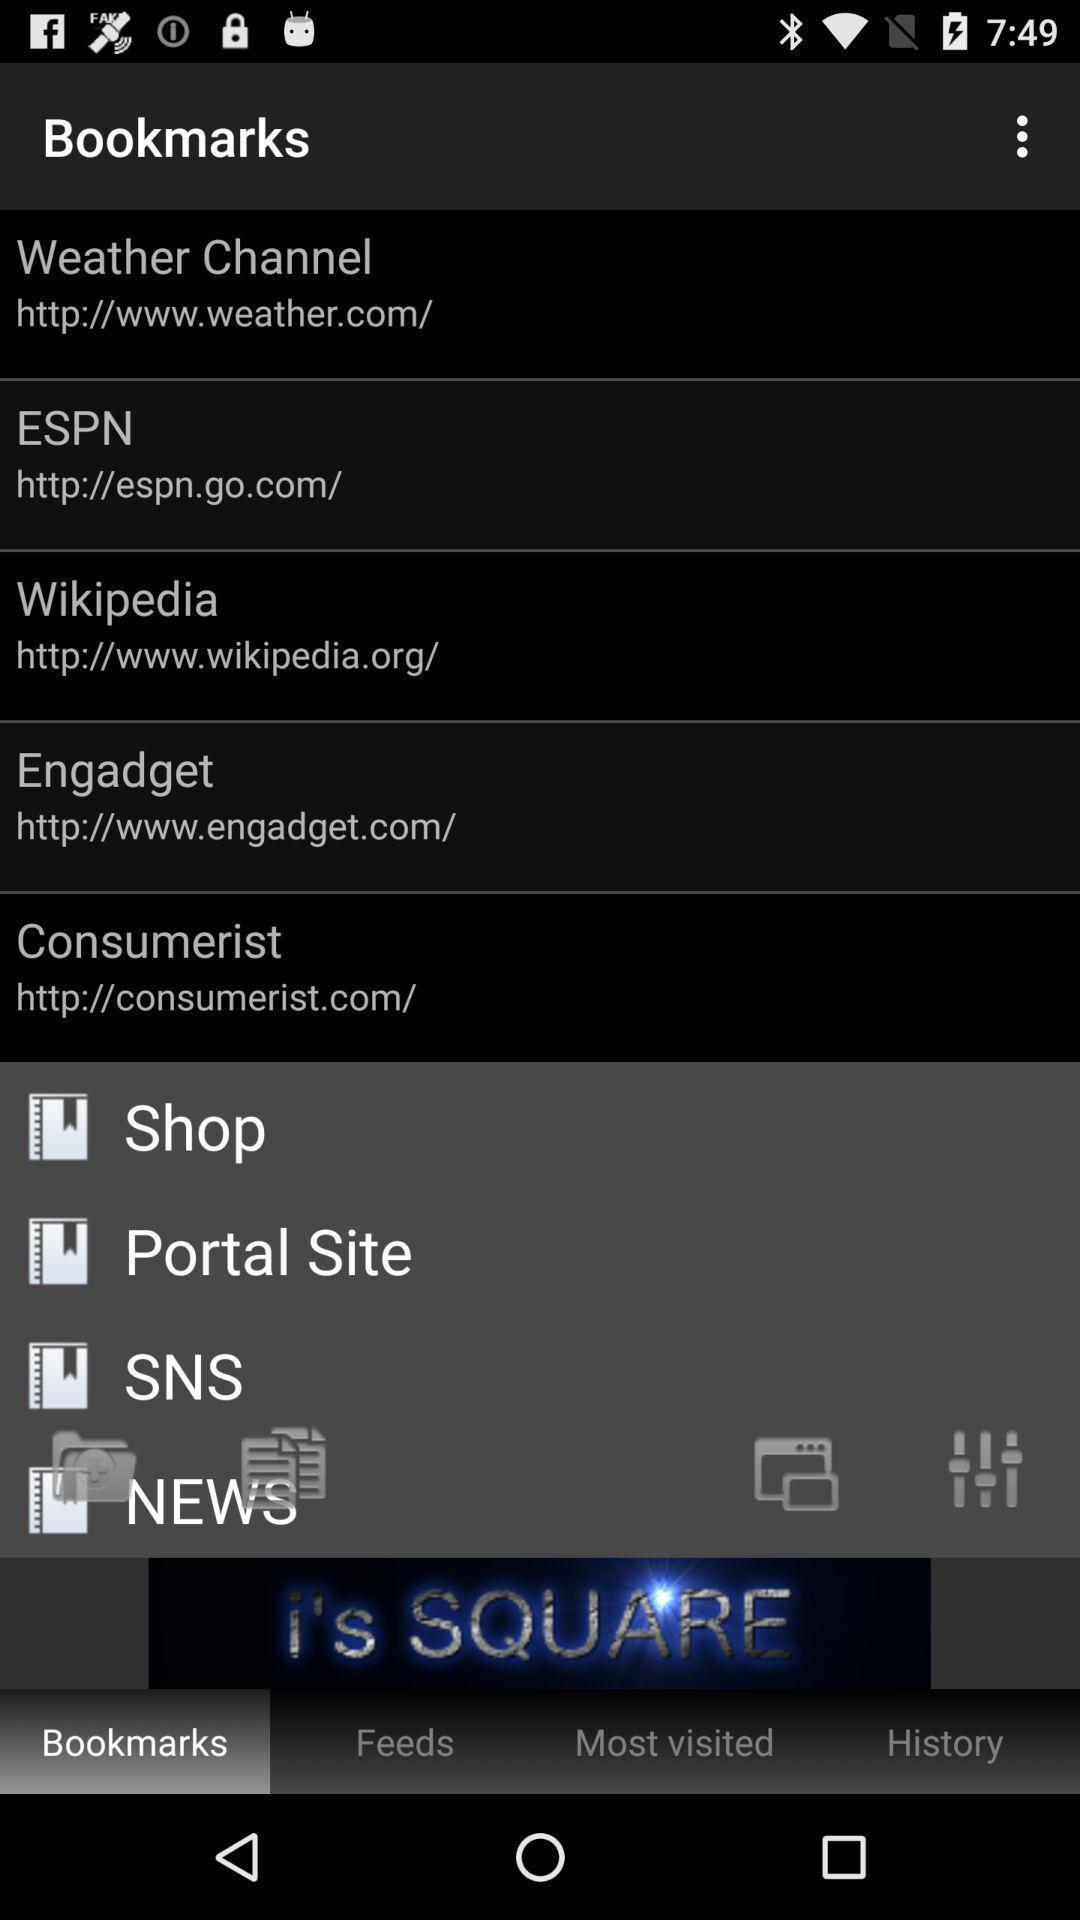What is the URL of "Engadget"? The URL of "Engadget" is http://www.engadget.com/. 